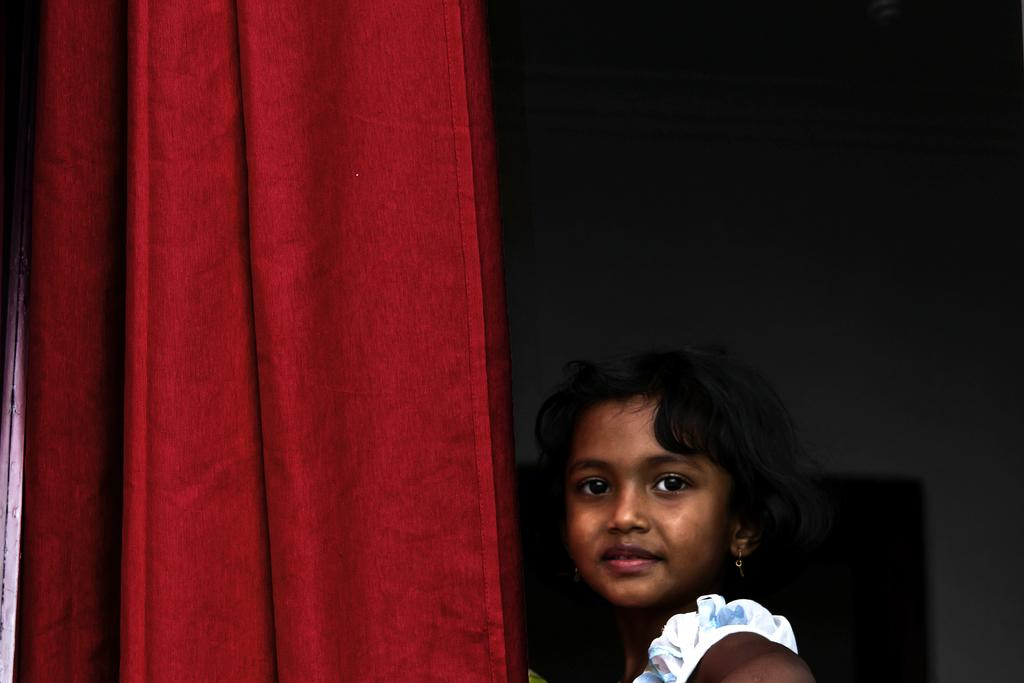Who is the main subject in the image? There is a girl in the center of the image. What can be seen on the left side of the image? There is a curtain on the left side of the image. What is visible in the background of the image? There is a wall in the background of the image. What type of sugar is being used to treat the disease in the image? There is no sugar or disease present in the image. 